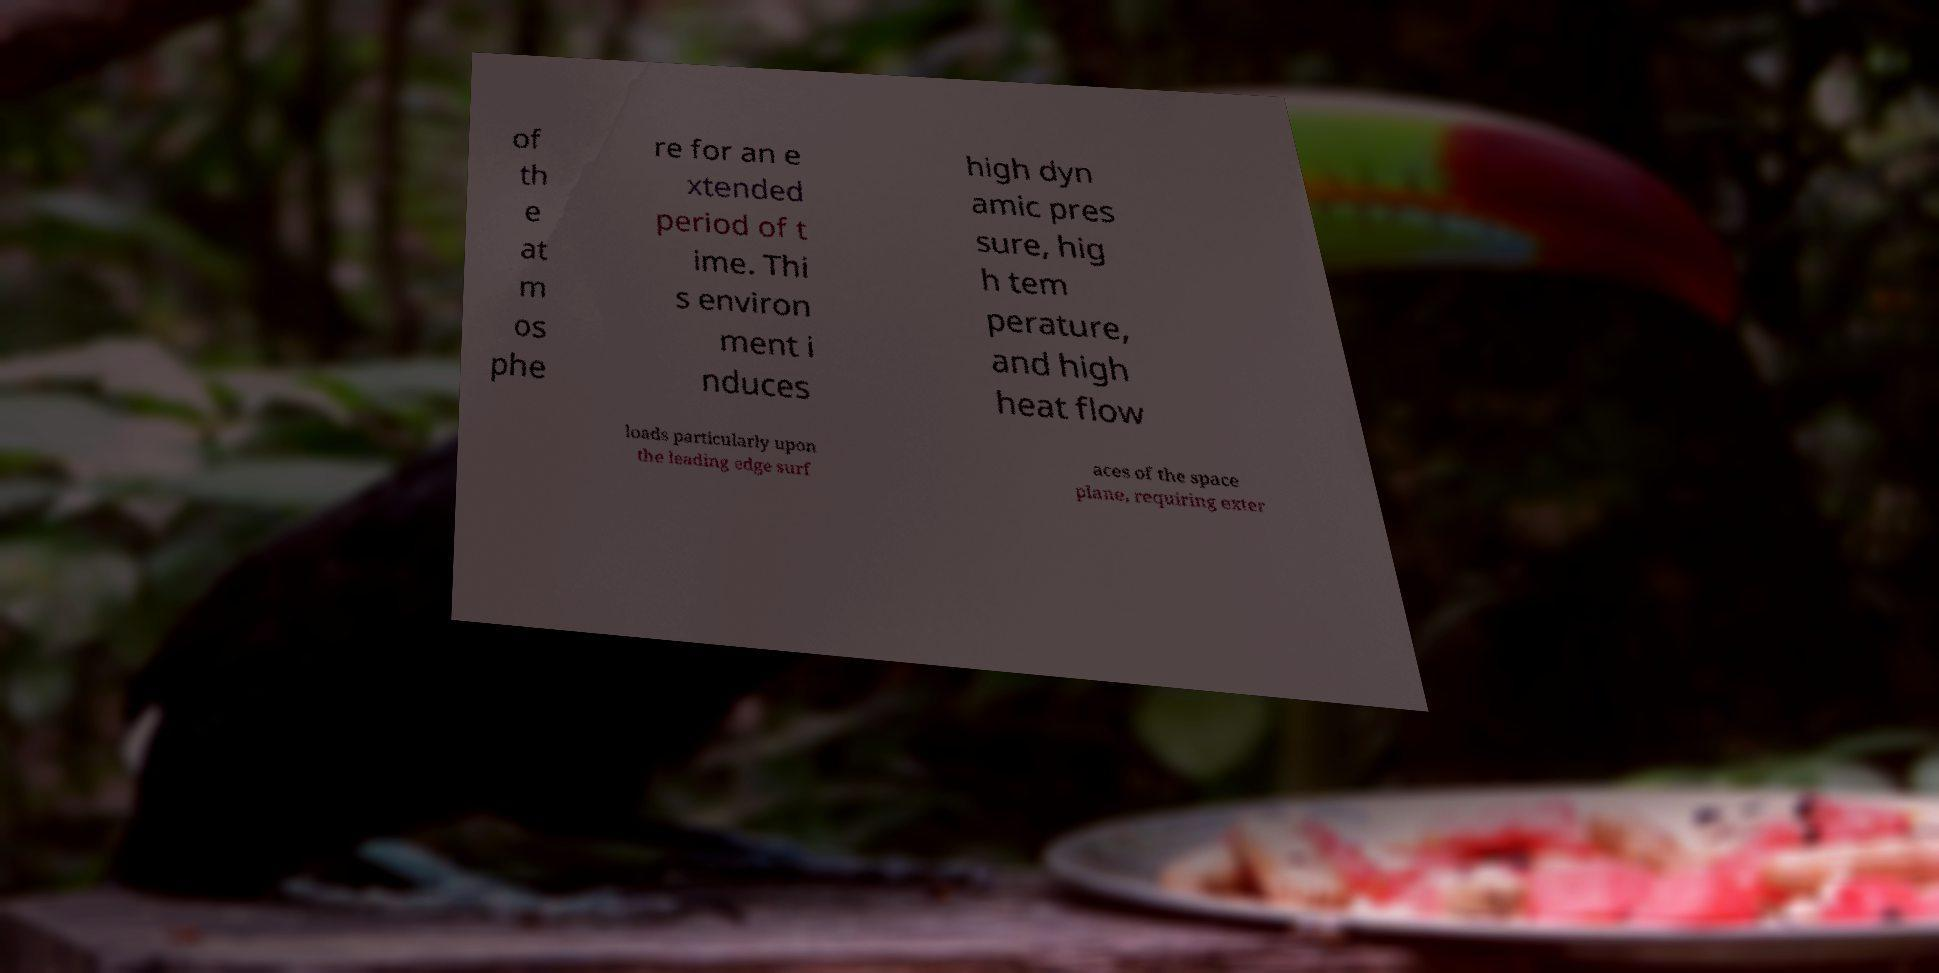Please identify and transcribe the text found in this image. of th e at m os phe re for an e xtended period of t ime. Thi s environ ment i nduces high dyn amic pres sure, hig h tem perature, and high heat flow loads particularly upon the leading edge surf aces of the space plane, requiring exter 